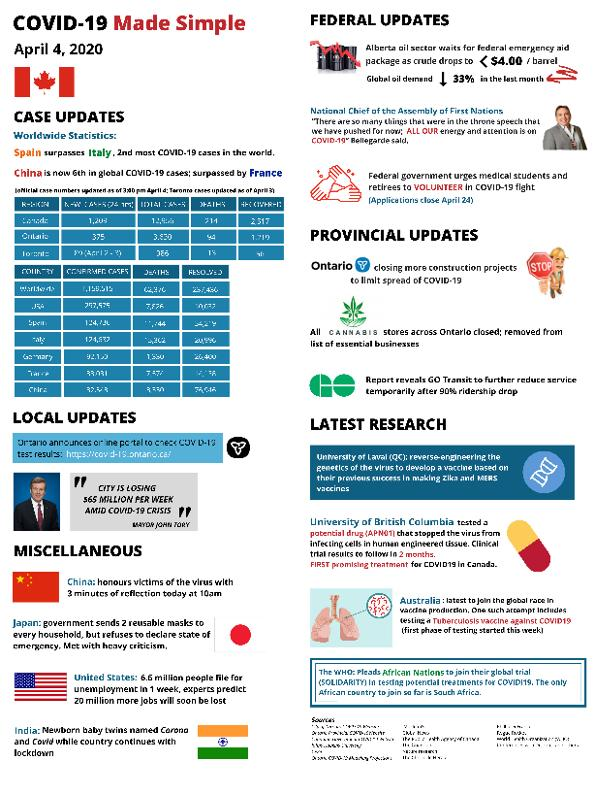List a handful of essential elements in this visual. As of April 4, 2020, according to the worldwide statistics of Covid-19, Italy is the country with the second highest number of recorded cases. As of April 4, 2020, Spain is reported to have the highest number of recorded Covid-19 cases worldwide. 